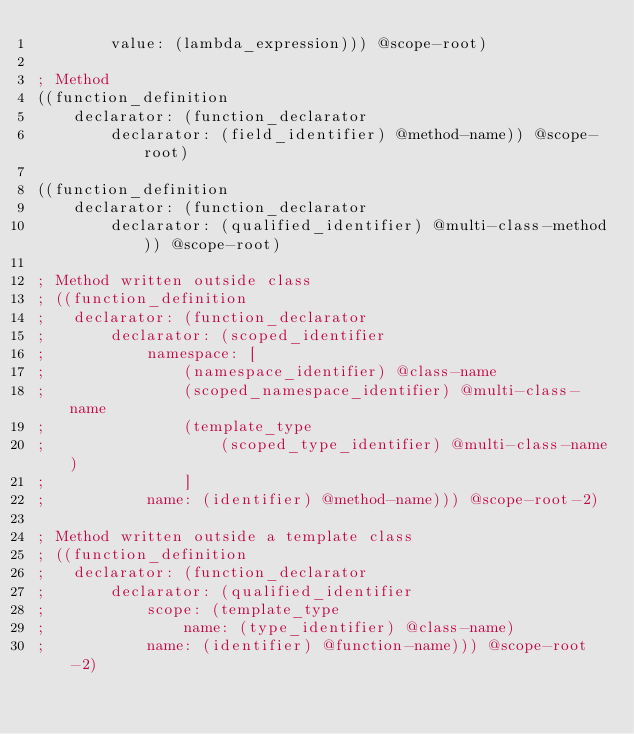Convert code to text. <code><loc_0><loc_0><loc_500><loc_500><_Scheme_>		value: (lambda_expression))) @scope-root)

; Method
((function_definition
	declarator: (function_declarator
		declarator: (field_identifier) @method-name)) @scope-root)

((function_definition
	declarator: (function_declarator
		declarator: (qualified_identifier) @multi-class-method)) @scope-root)

; Method written outside class
; ((function_definition
; 	declarator: (function_declarator
; 		declarator: (scoped_identifier
; 			namespace: [
; 				(namespace_identifier) @class-name
; 				(scoped_namespace_identifier) @multi-class-name
; 				(template_type
; 					(scoped_type_identifier) @multi-class-name)
; 				]
; 			name: (identifier) @method-name))) @scope-root-2)

; Method written outside a template class
; ((function_definition
; 	declarator: (function_declarator
; 		declarator: (qualified_identifier
; 			scope: (template_type
; 				name: (type_identifier) @class-name)
; 			name: (identifier) @function-name))) @scope-root-2)
</code> 